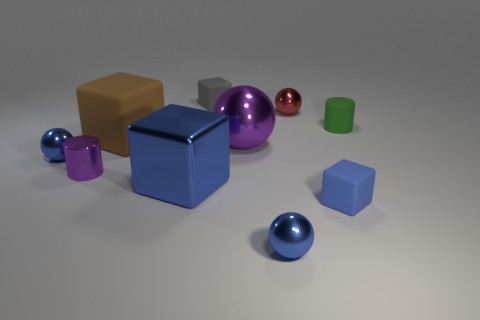Subtract all big brown rubber blocks. How many blocks are left? 3 Subtract all purple spheres. How many blue cubes are left? 2 Subtract all brown blocks. How many blocks are left? 3 Subtract 1 gray blocks. How many objects are left? 9 Subtract all cylinders. How many objects are left? 8 Subtract all gray spheres. Subtract all yellow cylinders. How many spheres are left? 4 Subtract all tiny cyan rubber cubes. Subtract all big blocks. How many objects are left? 8 Add 4 small blue metal objects. How many small blue metal objects are left? 6 Add 7 big yellow matte spheres. How many big yellow matte spheres exist? 7 